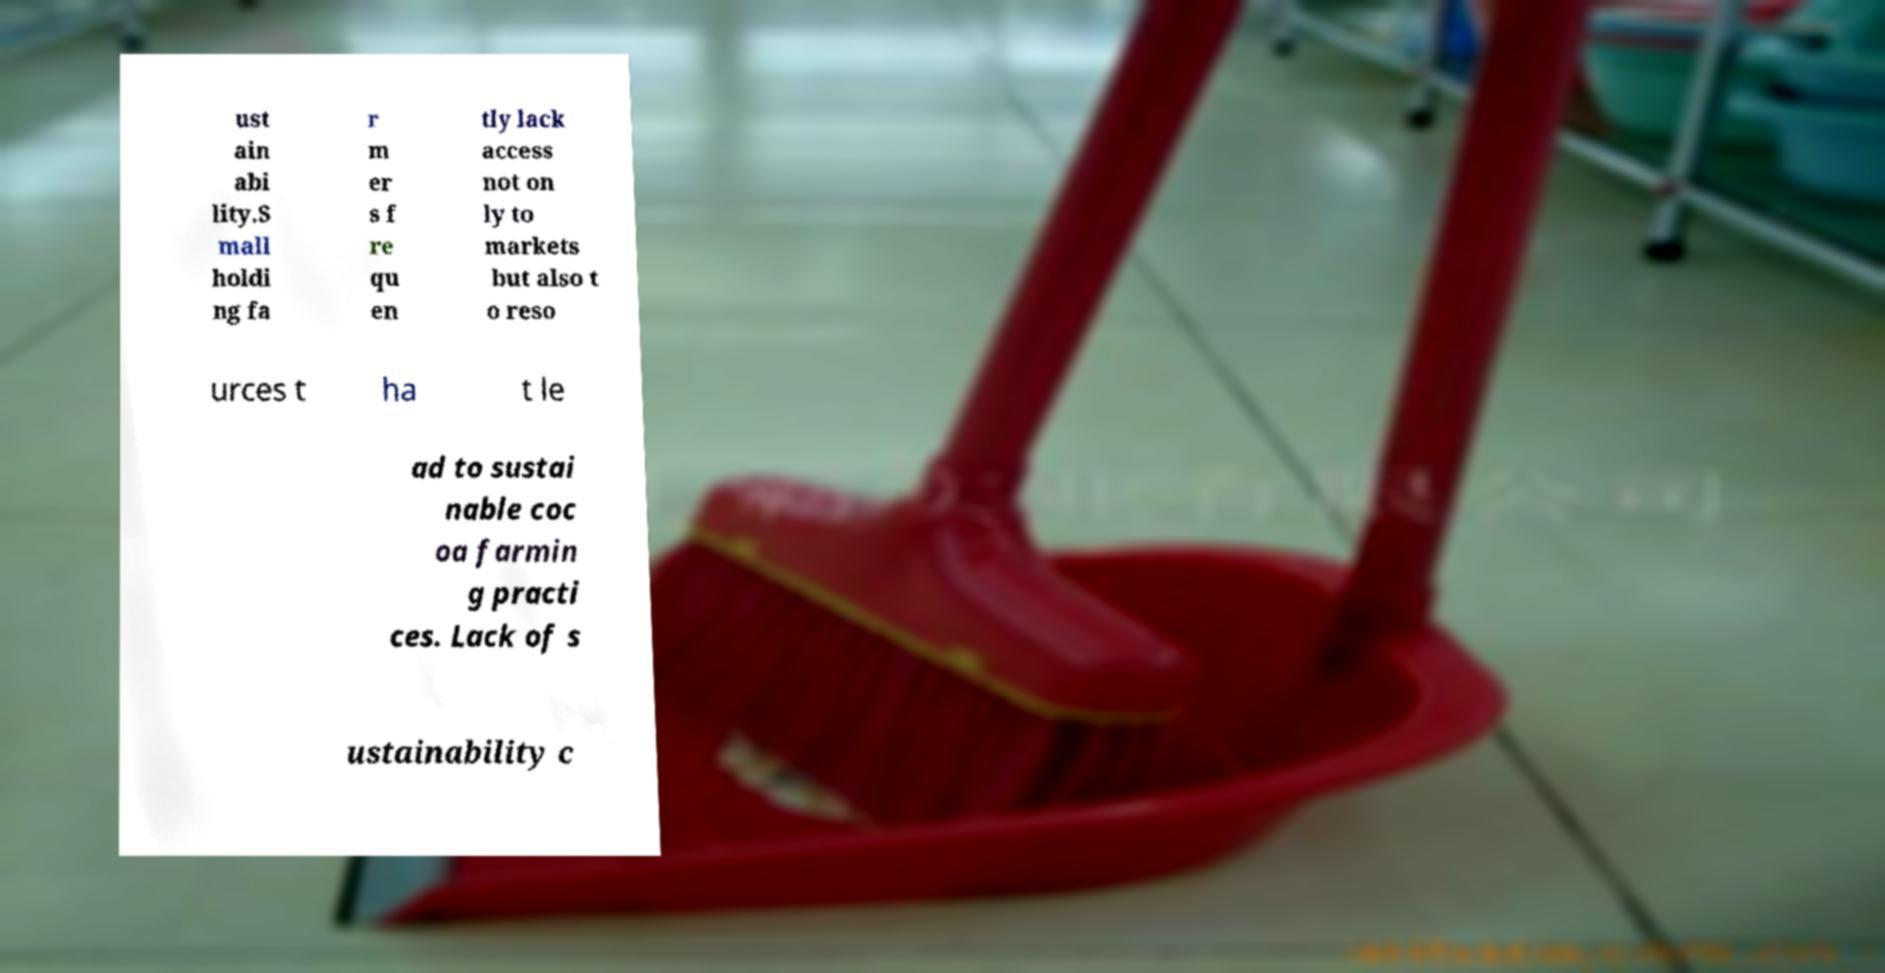Please identify and transcribe the text found in this image. ust ain abi lity.S mall holdi ng fa r m er s f re qu en tly lack access not on ly to markets but also t o reso urces t ha t le ad to sustai nable coc oa farmin g practi ces. Lack of s ustainability c 